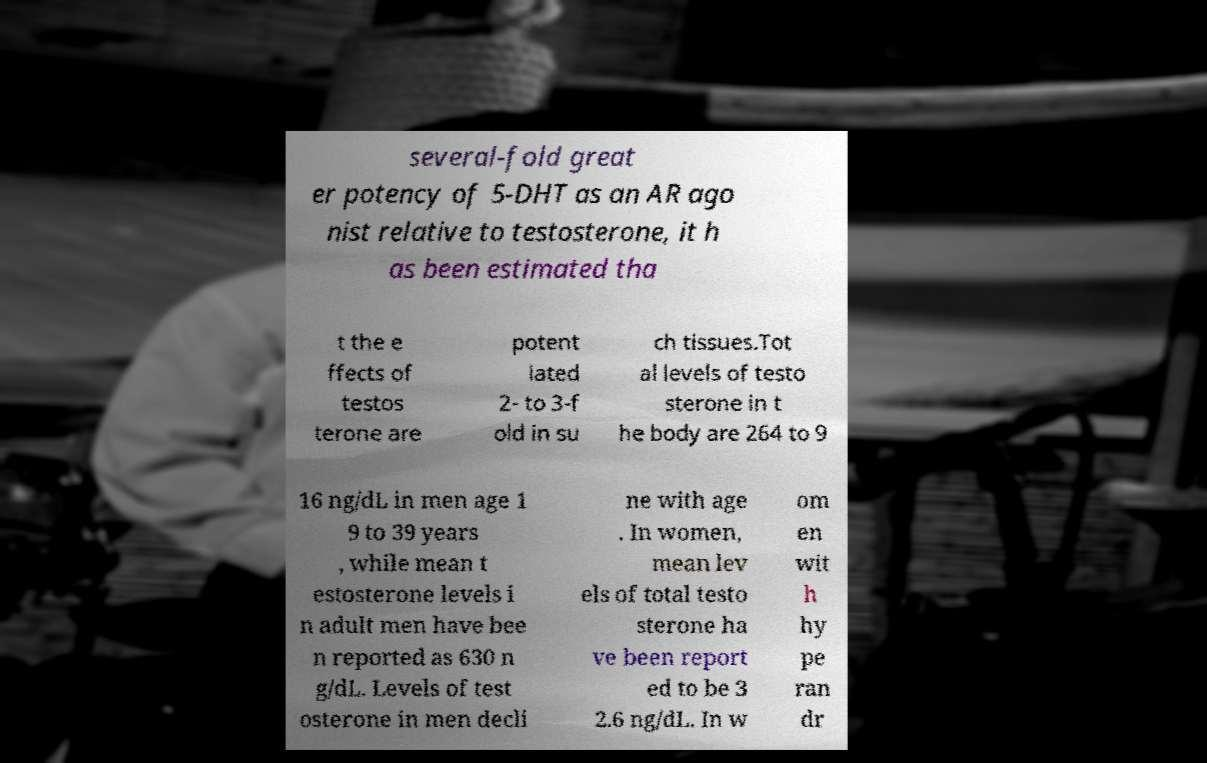There's text embedded in this image that I need extracted. Can you transcribe it verbatim? several-fold great er potency of 5-DHT as an AR ago nist relative to testosterone, it h as been estimated tha t the e ffects of testos terone are potent iated 2- to 3-f old in su ch tissues.Tot al levels of testo sterone in t he body are 264 to 9 16 ng/dL in men age 1 9 to 39 years , while mean t estosterone levels i n adult men have bee n reported as 630 n g/dL. Levels of test osterone in men decli ne with age . In women, mean lev els of total testo sterone ha ve been report ed to be 3 2.6 ng/dL. In w om en wit h hy pe ran dr 